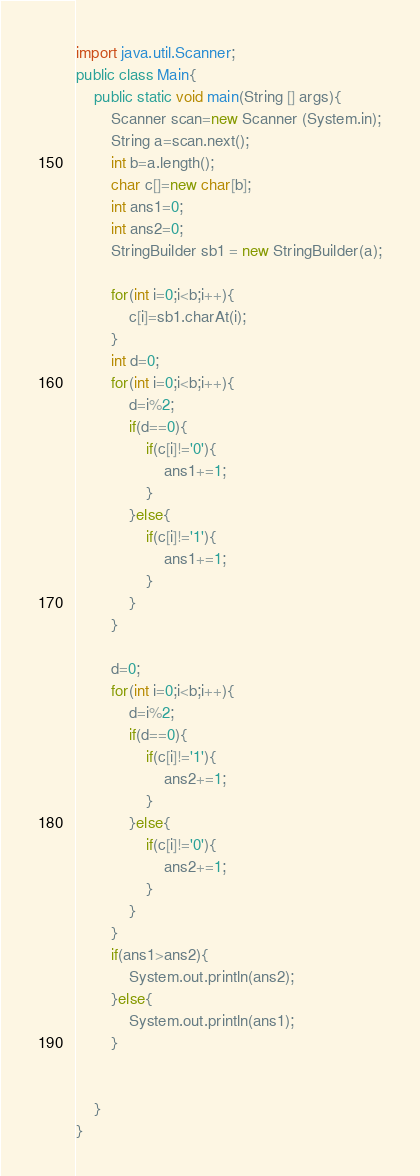Convert code to text. <code><loc_0><loc_0><loc_500><loc_500><_Java_>import java.util.Scanner;
public class Main{
    public static void main(String [] args){
        Scanner scan=new Scanner (System.in);
        String a=scan.next();
        int b=a.length();
        char c[]=new char[b];
        int ans1=0;
        int ans2=0;
        StringBuilder sb1 = new StringBuilder(a);

        for(int i=0;i<b;i++){
            c[i]=sb1.charAt(i);
        }
        int d=0;
        for(int i=0;i<b;i++){
            d=i%2;
            if(d==0){
                if(c[i]!='0'){
                    ans1+=1;
                }
            }else{
                if(c[i]!='1'){
                    ans1+=1;
                }
            }
        }

        d=0;
        for(int i=0;i<b;i++){
        	d=i%2;
            if(d==0){
                if(c[i]!='1'){
                    ans2+=1;
                }
            }else{
                if(c[i]!='0'){
                    ans2+=1;
                }
            }
        }
        if(ans1>ans2){
            System.out.println(ans2);
        }else{
            System.out.println(ans1);
        }


    }
}</code> 